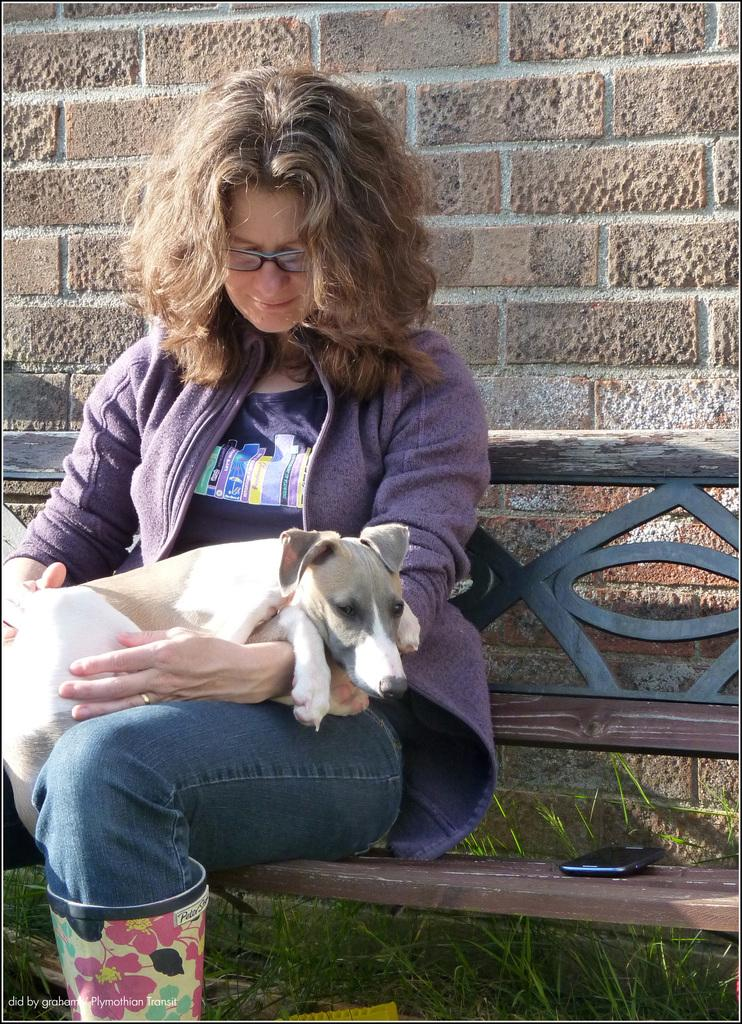Who is present in the image? There is a woman in the image. What is the woman doing in the image? The woman is sitting on a bench. What is the woman holding in the image? The woman is holding a dog. What else can be seen on the bench in the image? There is a mobile on the bench. What can be seen in the background of the image? There is to the bench and the woman? What type of fan is being used to paint the wall in the image? There is no fan or painting activity present in the image. The woman is sitting on a bench holding a dog, and there is a mobile on the bench as well. 